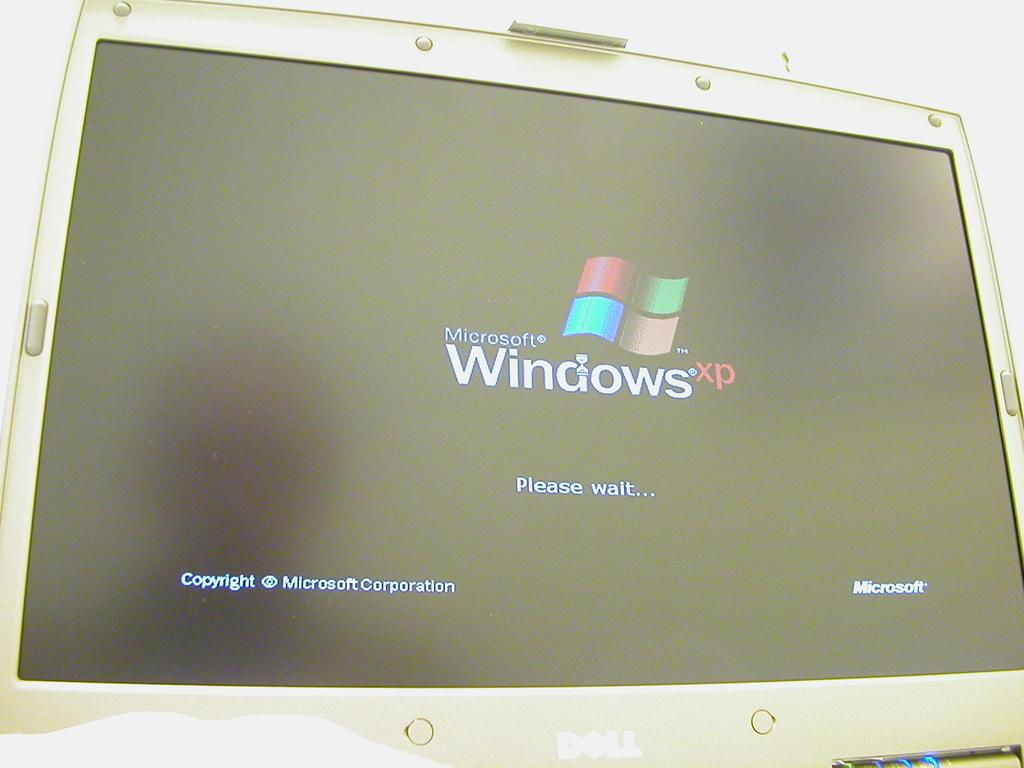<image>
Write a terse but informative summary of the picture. a dell computer screen on showing the windows xp logo on it 